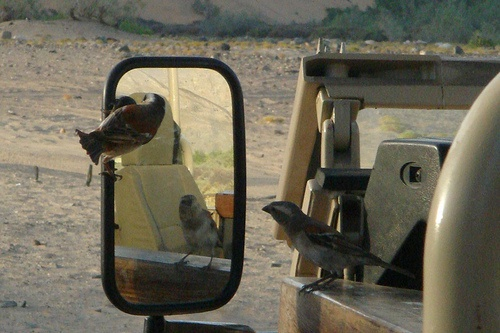Describe the objects in this image and their specific colors. I can see bird in teal, black, gray, and darkgray tones, bird in teal, black, and gray tones, and bird in teal, black, and gray tones in this image. 